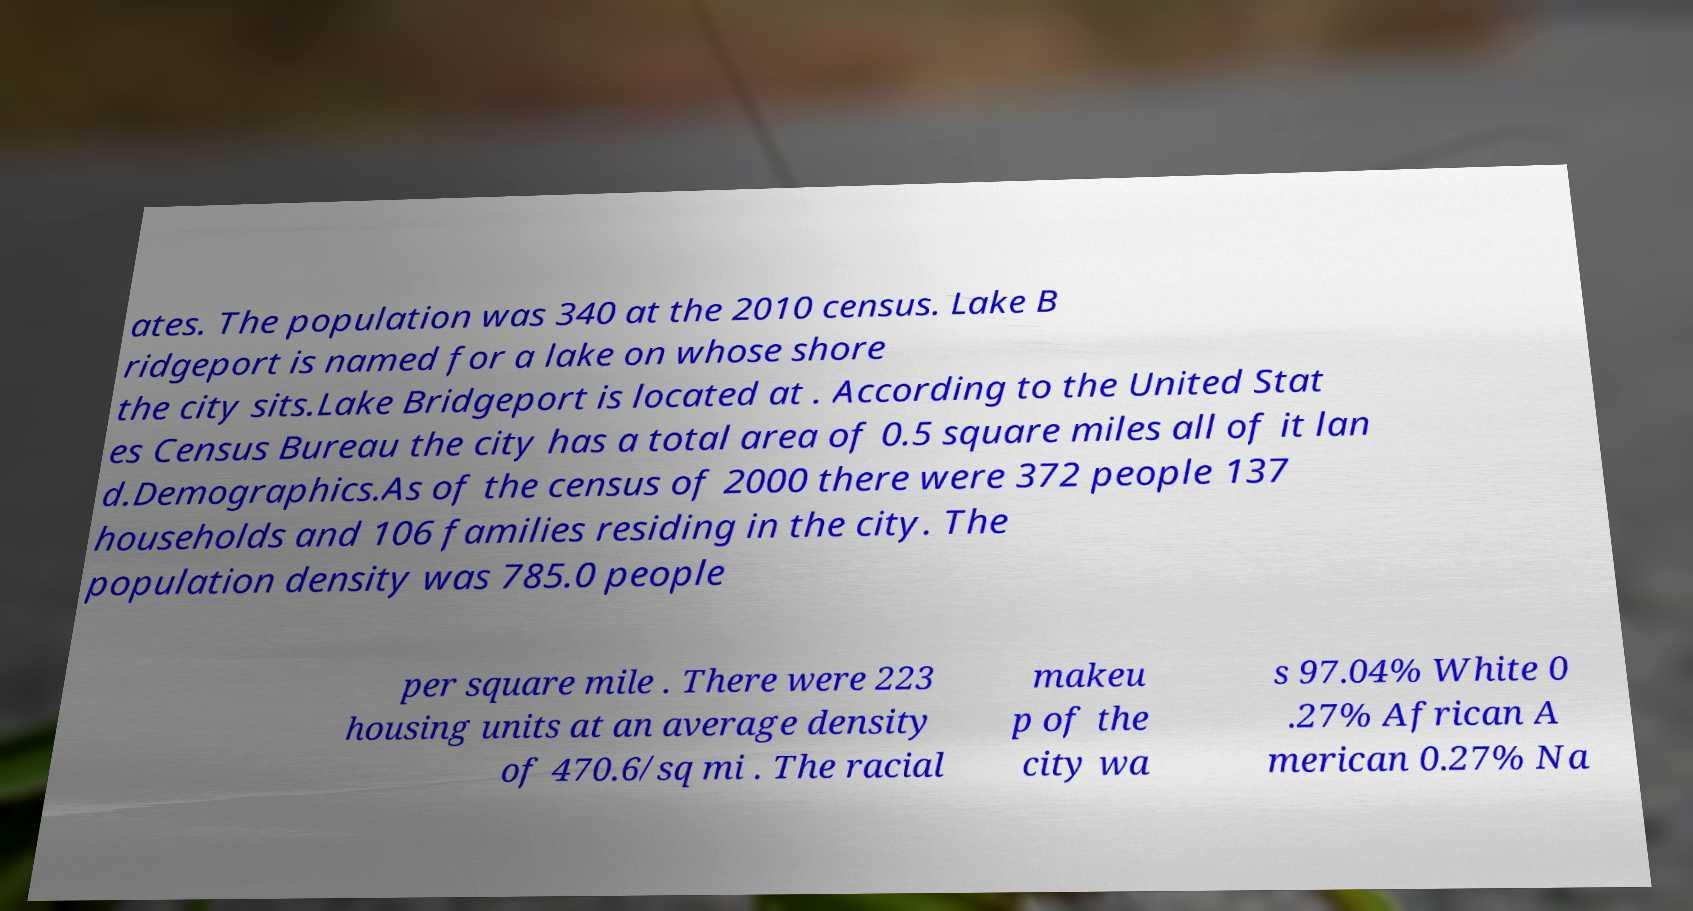Can you read and provide the text displayed in the image?This photo seems to have some interesting text. Can you extract and type it out for me? ates. The population was 340 at the 2010 census. Lake B ridgeport is named for a lake on whose shore the city sits.Lake Bridgeport is located at . According to the United Stat es Census Bureau the city has a total area of 0.5 square miles all of it lan d.Demographics.As of the census of 2000 there were 372 people 137 households and 106 families residing in the city. The population density was 785.0 people per square mile . There were 223 housing units at an average density of 470.6/sq mi . The racial makeu p of the city wa s 97.04% White 0 .27% African A merican 0.27% Na 